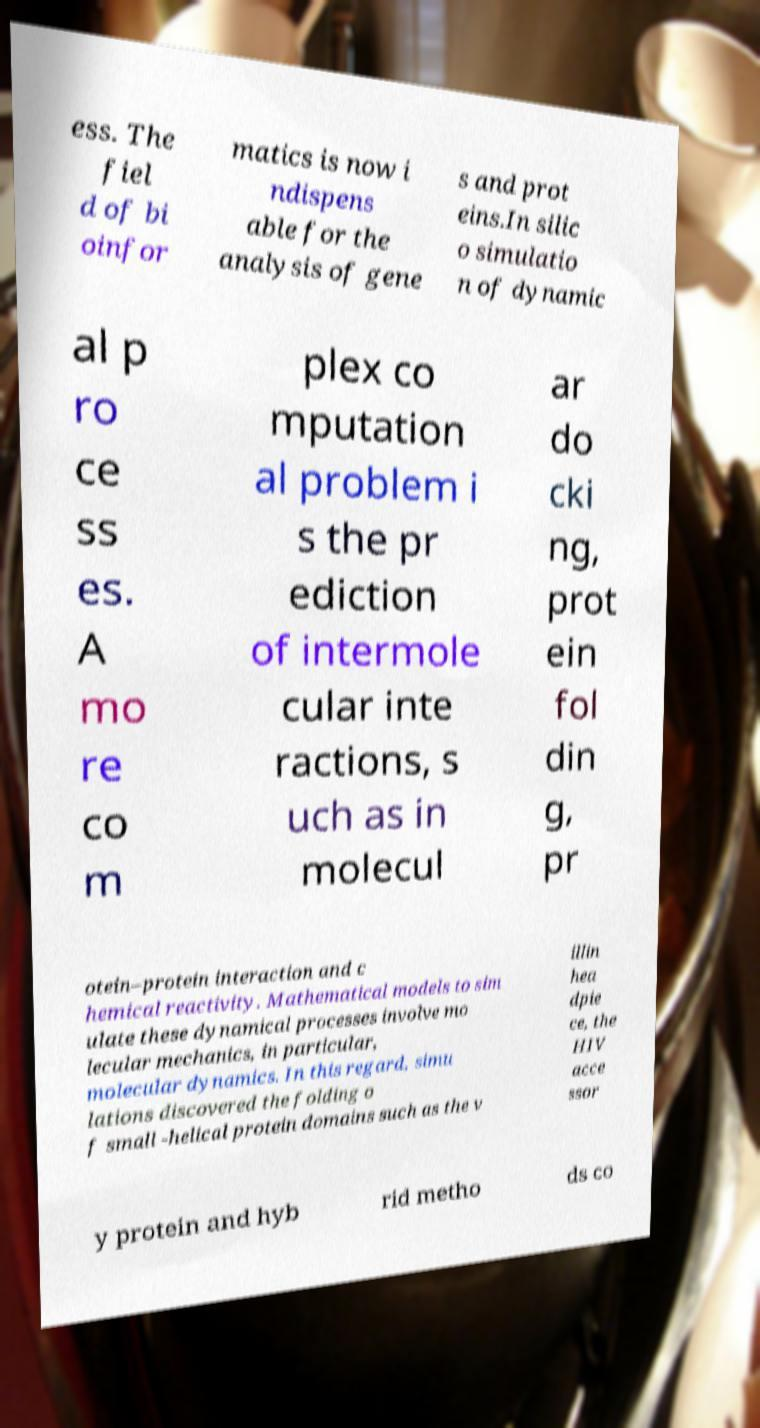Could you assist in decoding the text presented in this image and type it out clearly? ess. The fiel d of bi oinfor matics is now i ndispens able for the analysis of gene s and prot eins.In silic o simulatio n of dynamic al p ro ce ss es. A mo re co m plex co mputation al problem i s the pr ediction of intermole cular inte ractions, s uch as in molecul ar do cki ng, prot ein fol din g, pr otein–protein interaction and c hemical reactivity. Mathematical models to sim ulate these dynamical processes involve mo lecular mechanics, in particular, molecular dynamics. In this regard, simu lations discovered the folding o f small -helical protein domains such as the v illin hea dpie ce, the HIV acce ssor y protein and hyb rid metho ds co 